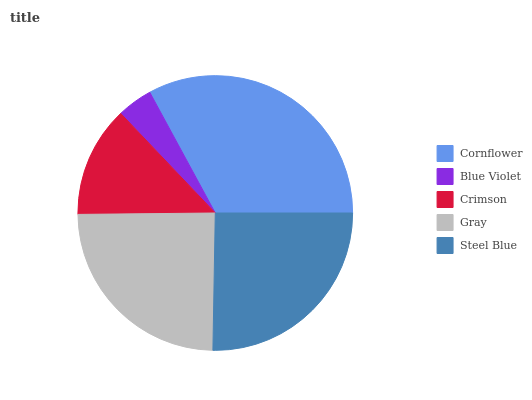Is Blue Violet the minimum?
Answer yes or no. Yes. Is Cornflower the maximum?
Answer yes or no. Yes. Is Crimson the minimum?
Answer yes or no. No. Is Crimson the maximum?
Answer yes or no. No. Is Crimson greater than Blue Violet?
Answer yes or no. Yes. Is Blue Violet less than Crimson?
Answer yes or no. Yes. Is Blue Violet greater than Crimson?
Answer yes or no. No. Is Crimson less than Blue Violet?
Answer yes or no. No. Is Gray the high median?
Answer yes or no. Yes. Is Gray the low median?
Answer yes or no. Yes. Is Steel Blue the high median?
Answer yes or no. No. Is Crimson the low median?
Answer yes or no. No. 